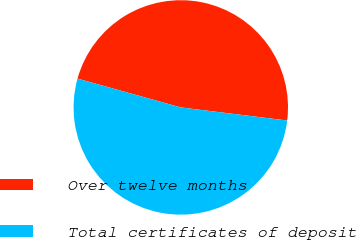Convert chart to OTSL. <chart><loc_0><loc_0><loc_500><loc_500><pie_chart><fcel>Over twelve months<fcel>Total certificates of deposit<nl><fcel>47.62%<fcel>52.38%<nl></chart> 